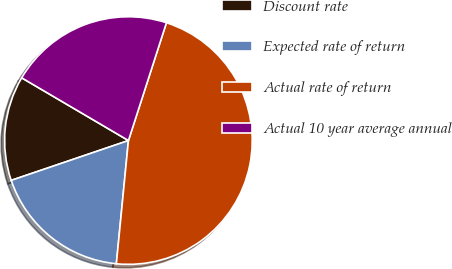<chart> <loc_0><loc_0><loc_500><loc_500><pie_chart><fcel>Discount rate<fcel>Expected rate of return<fcel>Actual rate of return<fcel>Actual 10 year average annual<nl><fcel>13.67%<fcel>18.23%<fcel>46.59%<fcel>21.51%<nl></chart> 